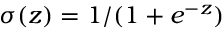<formula> <loc_0><loc_0><loc_500><loc_500>\sigma ( z ) = 1 / ( 1 + e ^ { - z } )</formula> 